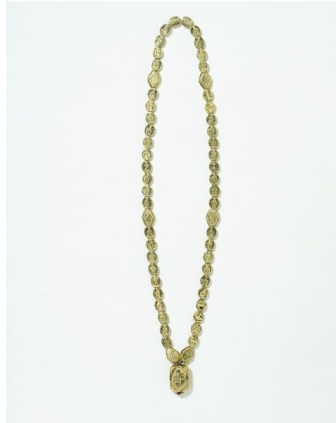What's happening in the scene? The image presents a beautifully designed necklace set against a pristine white background. This necklace features a series of small, uniformly colored golden beads leading to a prominent pendant that serves as the centerpiece. The pendant, circular in design, is intricately etched with a floral pattern, exuding elegance and sophistication. The vivid juxtaposition of the golden necklace against the stark white background enhances the visual appeal, ensuring that the intricacies of the necklace and pendant are fully appreciated. 